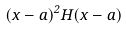Convert formula to latex. <formula><loc_0><loc_0><loc_500><loc_500>( x - a ) ^ { 2 } H ( x - a )</formula> 